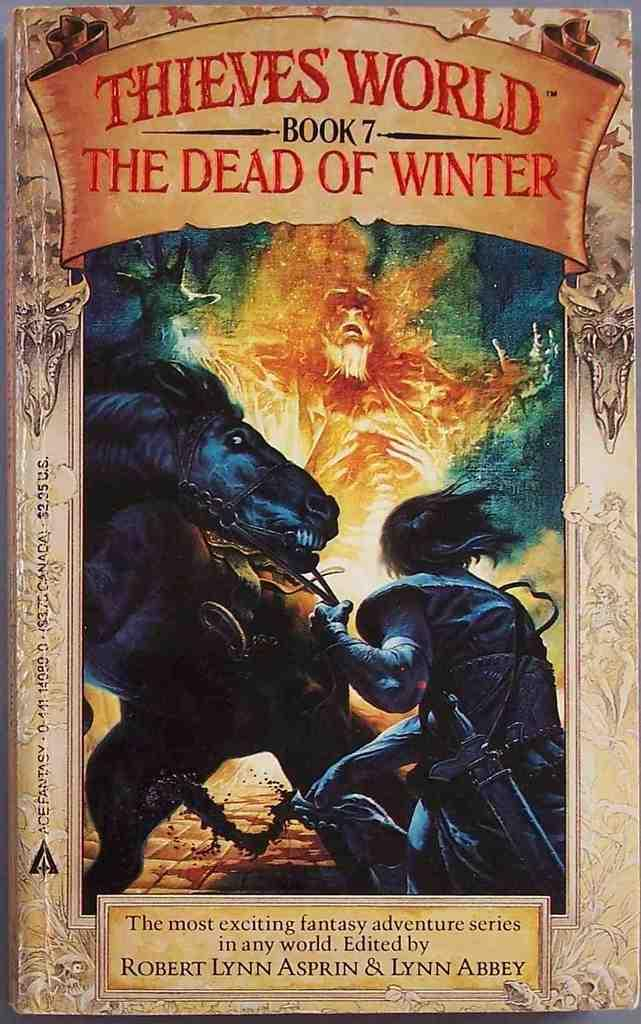Provide a one-sentence caption for the provided image. Here we have a book cover for book 7 in the Thieves World series titled The Dead of Winter. 